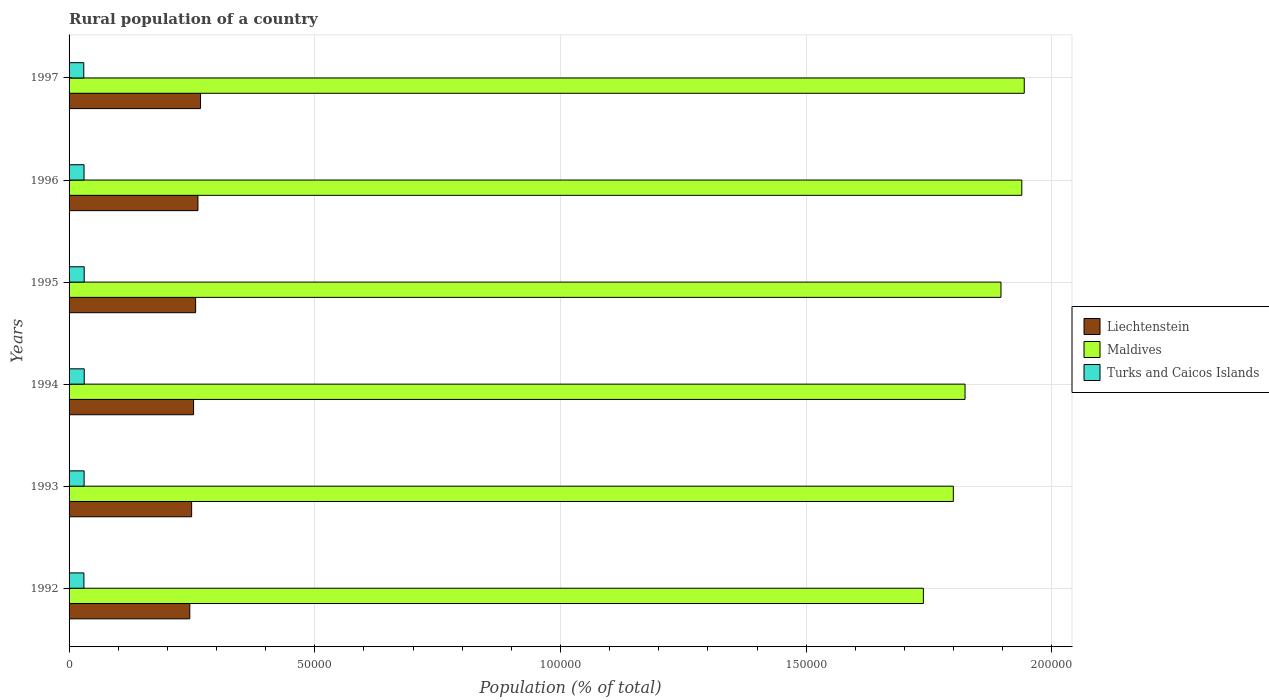How many groups of bars are there?
Your answer should be compact. 6. How many bars are there on the 3rd tick from the top?
Your answer should be compact. 3. In how many cases, is the number of bars for a given year not equal to the number of legend labels?
Give a very brief answer. 0. What is the rural population in Liechtenstein in 1997?
Offer a very short reply. 2.67e+04. Across all years, what is the maximum rural population in Liechtenstein?
Keep it short and to the point. 2.67e+04. Across all years, what is the minimum rural population in Liechtenstein?
Offer a very short reply. 2.46e+04. In which year was the rural population in Maldives minimum?
Make the answer very short. 1992. What is the total rural population in Liechtenstein in the graph?
Provide a short and direct response. 1.54e+05. What is the difference between the rural population in Turks and Caicos Islands in 1994 and that in 1995?
Keep it short and to the point. 4. What is the difference between the rural population in Liechtenstein in 1993 and the rural population in Turks and Caicos Islands in 1995?
Your answer should be very brief. 2.19e+04. What is the average rural population in Liechtenstein per year?
Offer a very short reply. 2.56e+04. In the year 1993, what is the difference between the rural population in Maldives and rural population in Turks and Caicos Islands?
Offer a terse response. 1.77e+05. In how many years, is the rural population in Turks and Caicos Islands greater than 170000 %?
Provide a succinct answer. 0. What is the ratio of the rural population in Liechtenstein in 1992 to that in 1997?
Make the answer very short. 0.92. What is the difference between the highest and the second highest rural population in Turks and Caicos Islands?
Your answer should be compact. 4. What is the difference between the highest and the lowest rural population in Turks and Caicos Islands?
Provide a succinct answer. 89. In how many years, is the rural population in Liechtenstein greater than the average rural population in Liechtenstein taken over all years?
Provide a succinct answer. 3. What does the 3rd bar from the top in 1994 represents?
Your answer should be very brief. Liechtenstein. What does the 1st bar from the bottom in 1993 represents?
Provide a succinct answer. Liechtenstein. Is it the case that in every year, the sum of the rural population in Maldives and rural population in Turks and Caicos Islands is greater than the rural population in Liechtenstein?
Your response must be concise. Yes. How many bars are there?
Provide a succinct answer. 18. How many years are there in the graph?
Your answer should be compact. 6. Are the values on the major ticks of X-axis written in scientific E-notation?
Keep it short and to the point. No. Does the graph contain any zero values?
Offer a terse response. No. Where does the legend appear in the graph?
Give a very brief answer. Center right. How are the legend labels stacked?
Your answer should be compact. Vertical. What is the title of the graph?
Your answer should be compact. Rural population of a country. What is the label or title of the X-axis?
Make the answer very short. Population (% of total). What is the Population (% of total) in Liechtenstein in 1992?
Ensure brevity in your answer.  2.46e+04. What is the Population (% of total) in Maldives in 1992?
Offer a very short reply. 1.74e+05. What is the Population (% of total) of Turks and Caicos Islands in 1992?
Your response must be concise. 3023. What is the Population (% of total) of Liechtenstein in 1993?
Provide a short and direct response. 2.49e+04. What is the Population (% of total) of Maldives in 1993?
Offer a terse response. 1.80e+05. What is the Population (% of total) in Turks and Caicos Islands in 1993?
Provide a short and direct response. 3061. What is the Population (% of total) of Liechtenstein in 1994?
Make the answer very short. 2.53e+04. What is the Population (% of total) of Maldives in 1994?
Make the answer very short. 1.82e+05. What is the Population (% of total) in Turks and Caicos Islands in 1994?
Keep it short and to the point. 3082. What is the Population (% of total) of Liechtenstein in 1995?
Your answer should be very brief. 2.58e+04. What is the Population (% of total) of Maldives in 1995?
Your response must be concise. 1.90e+05. What is the Population (% of total) in Turks and Caicos Islands in 1995?
Your answer should be very brief. 3078. What is the Population (% of total) of Liechtenstein in 1996?
Give a very brief answer. 2.62e+04. What is the Population (% of total) of Maldives in 1996?
Offer a terse response. 1.94e+05. What is the Population (% of total) of Turks and Caicos Islands in 1996?
Your answer should be very brief. 3045. What is the Population (% of total) of Liechtenstein in 1997?
Make the answer very short. 2.67e+04. What is the Population (% of total) in Maldives in 1997?
Offer a terse response. 1.94e+05. What is the Population (% of total) of Turks and Caicos Islands in 1997?
Provide a short and direct response. 2993. Across all years, what is the maximum Population (% of total) in Liechtenstein?
Ensure brevity in your answer.  2.67e+04. Across all years, what is the maximum Population (% of total) of Maldives?
Your answer should be compact. 1.94e+05. Across all years, what is the maximum Population (% of total) in Turks and Caicos Islands?
Your answer should be compact. 3082. Across all years, what is the minimum Population (% of total) in Liechtenstein?
Provide a short and direct response. 2.46e+04. Across all years, what is the minimum Population (% of total) of Maldives?
Your answer should be compact. 1.74e+05. Across all years, what is the minimum Population (% of total) of Turks and Caicos Islands?
Your response must be concise. 2993. What is the total Population (% of total) in Liechtenstein in the graph?
Ensure brevity in your answer.  1.54e+05. What is the total Population (% of total) in Maldives in the graph?
Provide a succinct answer. 1.11e+06. What is the total Population (% of total) in Turks and Caicos Islands in the graph?
Offer a very short reply. 1.83e+04. What is the difference between the Population (% of total) in Liechtenstein in 1992 and that in 1993?
Provide a short and direct response. -374. What is the difference between the Population (% of total) of Maldives in 1992 and that in 1993?
Provide a short and direct response. -6097. What is the difference between the Population (% of total) of Turks and Caicos Islands in 1992 and that in 1993?
Offer a terse response. -38. What is the difference between the Population (% of total) of Liechtenstein in 1992 and that in 1994?
Offer a very short reply. -770. What is the difference between the Population (% of total) of Maldives in 1992 and that in 1994?
Provide a short and direct response. -8482. What is the difference between the Population (% of total) of Turks and Caicos Islands in 1992 and that in 1994?
Provide a succinct answer. -59. What is the difference between the Population (% of total) of Liechtenstein in 1992 and that in 1995?
Your answer should be compact. -1186. What is the difference between the Population (% of total) of Maldives in 1992 and that in 1995?
Your answer should be compact. -1.58e+04. What is the difference between the Population (% of total) in Turks and Caicos Islands in 1992 and that in 1995?
Offer a terse response. -55. What is the difference between the Population (% of total) of Liechtenstein in 1992 and that in 1996?
Make the answer very short. -1659. What is the difference between the Population (% of total) of Maldives in 1992 and that in 1996?
Ensure brevity in your answer.  -2.00e+04. What is the difference between the Population (% of total) of Turks and Caicos Islands in 1992 and that in 1996?
Provide a succinct answer. -22. What is the difference between the Population (% of total) in Liechtenstein in 1992 and that in 1997?
Offer a very short reply. -2184. What is the difference between the Population (% of total) of Maldives in 1992 and that in 1997?
Keep it short and to the point. -2.05e+04. What is the difference between the Population (% of total) of Liechtenstein in 1993 and that in 1994?
Your response must be concise. -396. What is the difference between the Population (% of total) of Maldives in 1993 and that in 1994?
Your response must be concise. -2385. What is the difference between the Population (% of total) in Turks and Caicos Islands in 1993 and that in 1994?
Offer a very short reply. -21. What is the difference between the Population (% of total) of Liechtenstein in 1993 and that in 1995?
Provide a short and direct response. -812. What is the difference between the Population (% of total) of Maldives in 1993 and that in 1995?
Keep it short and to the point. -9694. What is the difference between the Population (% of total) of Turks and Caicos Islands in 1993 and that in 1995?
Provide a short and direct response. -17. What is the difference between the Population (% of total) of Liechtenstein in 1993 and that in 1996?
Provide a succinct answer. -1285. What is the difference between the Population (% of total) of Maldives in 1993 and that in 1996?
Keep it short and to the point. -1.39e+04. What is the difference between the Population (% of total) in Turks and Caicos Islands in 1993 and that in 1996?
Your response must be concise. 16. What is the difference between the Population (% of total) of Liechtenstein in 1993 and that in 1997?
Give a very brief answer. -1810. What is the difference between the Population (% of total) in Maldives in 1993 and that in 1997?
Provide a succinct answer. -1.44e+04. What is the difference between the Population (% of total) of Turks and Caicos Islands in 1993 and that in 1997?
Your answer should be compact. 68. What is the difference between the Population (% of total) in Liechtenstein in 1994 and that in 1995?
Your answer should be very brief. -416. What is the difference between the Population (% of total) of Maldives in 1994 and that in 1995?
Your answer should be compact. -7309. What is the difference between the Population (% of total) in Liechtenstein in 1994 and that in 1996?
Keep it short and to the point. -889. What is the difference between the Population (% of total) of Maldives in 1994 and that in 1996?
Provide a short and direct response. -1.15e+04. What is the difference between the Population (% of total) of Liechtenstein in 1994 and that in 1997?
Provide a short and direct response. -1414. What is the difference between the Population (% of total) of Maldives in 1994 and that in 1997?
Keep it short and to the point. -1.20e+04. What is the difference between the Population (% of total) of Turks and Caicos Islands in 1994 and that in 1997?
Offer a very short reply. 89. What is the difference between the Population (% of total) of Liechtenstein in 1995 and that in 1996?
Your answer should be compact. -473. What is the difference between the Population (% of total) in Maldives in 1995 and that in 1996?
Give a very brief answer. -4236. What is the difference between the Population (% of total) of Liechtenstein in 1995 and that in 1997?
Keep it short and to the point. -998. What is the difference between the Population (% of total) in Maldives in 1995 and that in 1997?
Provide a short and direct response. -4736. What is the difference between the Population (% of total) in Turks and Caicos Islands in 1995 and that in 1997?
Keep it short and to the point. 85. What is the difference between the Population (% of total) of Liechtenstein in 1996 and that in 1997?
Your answer should be very brief. -525. What is the difference between the Population (% of total) of Maldives in 1996 and that in 1997?
Your response must be concise. -500. What is the difference between the Population (% of total) of Turks and Caicos Islands in 1996 and that in 1997?
Make the answer very short. 52. What is the difference between the Population (% of total) in Liechtenstein in 1992 and the Population (% of total) in Maldives in 1993?
Provide a succinct answer. -1.55e+05. What is the difference between the Population (% of total) of Liechtenstein in 1992 and the Population (% of total) of Turks and Caicos Islands in 1993?
Keep it short and to the point. 2.15e+04. What is the difference between the Population (% of total) of Maldives in 1992 and the Population (% of total) of Turks and Caicos Islands in 1993?
Keep it short and to the point. 1.71e+05. What is the difference between the Population (% of total) in Liechtenstein in 1992 and the Population (% of total) in Maldives in 1994?
Offer a very short reply. -1.58e+05. What is the difference between the Population (% of total) in Liechtenstein in 1992 and the Population (% of total) in Turks and Caicos Islands in 1994?
Provide a short and direct response. 2.15e+04. What is the difference between the Population (% of total) of Maldives in 1992 and the Population (% of total) of Turks and Caicos Islands in 1994?
Keep it short and to the point. 1.71e+05. What is the difference between the Population (% of total) in Liechtenstein in 1992 and the Population (% of total) in Maldives in 1995?
Your answer should be compact. -1.65e+05. What is the difference between the Population (% of total) of Liechtenstein in 1992 and the Population (% of total) of Turks and Caicos Islands in 1995?
Ensure brevity in your answer.  2.15e+04. What is the difference between the Population (% of total) in Maldives in 1992 and the Population (% of total) in Turks and Caicos Islands in 1995?
Keep it short and to the point. 1.71e+05. What is the difference between the Population (% of total) of Liechtenstein in 1992 and the Population (% of total) of Maldives in 1996?
Your answer should be very brief. -1.69e+05. What is the difference between the Population (% of total) in Liechtenstein in 1992 and the Population (% of total) in Turks and Caicos Islands in 1996?
Keep it short and to the point. 2.15e+04. What is the difference between the Population (% of total) in Maldives in 1992 and the Population (% of total) in Turks and Caicos Islands in 1996?
Your answer should be very brief. 1.71e+05. What is the difference between the Population (% of total) of Liechtenstein in 1992 and the Population (% of total) of Maldives in 1997?
Provide a succinct answer. -1.70e+05. What is the difference between the Population (% of total) in Liechtenstein in 1992 and the Population (% of total) in Turks and Caicos Islands in 1997?
Provide a short and direct response. 2.16e+04. What is the difference between the Population (% of total) in Maldives in 1992 and the Population (% of total) in Turks and Caicos Islands in 1997?
Provide a succinct answer. 1.71e+05. What is the difference between the Population (% of total) of Liechtenstein in 1993 and the Population (% of total) of Maldives in 1994?
Your answer should be very brief. -1.57e+05. What is the difference between the Population (% of total) of Liechtenstein in 1993 and the Population (% of total) of Turks and Caicos Islands in 1994?
Your answer should be very brief. 2.19e+04. What is the difference between the Population (% of total) in Maldives in 1993 and the Population (% of total) in Turks and Caicos Islands in 1994?
Ensure brevity in your answer.  1.77e+05. What is the difference between the Population (% of total) of Liechtenstein in 1993 and the Population (% of total) of Maldives in 1995?
Your response must be concise. -1.65e+05. What is the difference between the Population (% of total) of Liechtenstein in 1993 and the Population (% of total) of Turks and Caicos Islands in 1995?
Your answer should be compact. 2.19e+04. What is the difference between the Population (% of total) in Maldives in 1993 and the Population (% of total) in Turks and Caicos Islands in 1995?
Give a very brief answer. 1.77e+05. What is the difference between the Population (% of total) in Liechtenstein in 1993 and the Population (% of total) in Maldives in 1996?
Provide a short and direct response. -1.69e+05. What is the difference between the Population (% of total) in Liechtenstein in 1993 and the Population (% of total) in Turks and Caicos Islands in 1996?
Make the answer very short. 2.19e+04. What is the difference between the Population (% of total) in Maldives in 1993 and the Population (% of total) in Turks and Caicos Islands in 1996?
Offer a terse response. 1.77e+05. What is the difference between the Population (% of total) in Liechtenstein in 1993 and the Population (% of total) in Maldives in 1997?
Provide a succinct answer. -1.69e+05. What is the difference between the Population (% of total) in Liechtenstein in 1993 and the Population (% of total) in Turks and Caicos Islands in 1997?
Make the answer very short. 2.19e+04. What is the difference between the Population (% of total) of Maldives in 1993 and the Population (% of total) of Turks and Caicos Islands in 1997?
Your answer should be very brief. 1.77e+05. What is the difference between the Population (% of total) in Liechtenstein in 1994 and the Population (% of total) in Maldives in 1995?
Give a very brief answer. -1.64e+05. What is the difference between the Population (% of total) in Liechtenstein in 1994 and the Population (% of total) in Turks and Caicos Islands in 1995?
Ensure brevity in your answer.  2.23e+04. What is the difference between the Population (% of total) of Maldives in 1994 and the Population (% of total) of Turks and Caicos Islands in 1995?
Offer a terse response. 1.79e+05. What is the difference between the Population (% of total) in Liechtenstein in 1994 and the Population (% of total) in Maldives in 1996?
Your response must be concise. -1.69e+05. What is the difference between the Population (% of total) of Liechtenstein in 1994 and the Population (% of total) of Turks and Caicos Islands in 1996?
Offer a very short reply. 2.23e+04. What is the difference between the Population (% of total) of Maldives in 1994 and the Population (% of total) of Turks and Caicos Islands in 1996?
Offer a very short reply. 1.79e+05. What is the difference between the Population (% of total) of Liechtenstein in 1994 and the Population (% of total) of Maldives in 1997?
Provide a succinct answer. -1.69e+05. What is the difference between the Population (% of total) of Liechtenstein in 1994 and the Population (% of total) of Turks and Caicos Islands in 1997?
Offer a terse response. 2.23e+04. What is the difference between the Population (% of total) of Maldives in 1994 and the Population (% of total) of Turks and Caicos Islands in 1997?
Provide a short and direct response. 1.79e+05. What is the difference between the Population (% of total) in Liechtenstein in 1995 and the Population (% of total) in Maldives in 1996?
Your response must be concise. -1.68e+05. What is the difference between the Population (% of total) in Liechtenstein in 1995 and the Population (% of total) in Turks and Caicos Islands in 1996?
Keep it short and to the point. 2.27e+04. What is the difference between the Population (% of total) of Maldives in 1995 and the Population (% of total) of Turks and Caicos Islands in 1996?
Make the answer very short. 1.87e+05. What is the difference between the Population (% of total) in Liechtenstein in 1995 and the Population (% of total) in Maldives in 1997?
Provide a short and direct response. -1.69e+05. What is the difference between the Population (% of total) of Liechtenstein in 1995 and the Population (% of total) of Turks and Caicos Islands in 1997?
Provide a short and direct response. 2.28e+04. What is the difference between the Population (% of total) of Maldives in 1995 and the Population (% of total) of Turks and Caicos Islands in 1997?
Offer a very short reply. 1.87e+05. What is the difference between the Population (% of total) in Liechtenstein in 1996 and the Population (% of total) in Maldives in 1997?
Your answer should be compact. -1.68e+05. What is the difference between the Population (% of total) in Liechtenstein in 1996 and the Population (% of total) in Turks and Caicos Islands in 1997?
Provide a succinct answer. 2.32e+04. What is the difference between the Population (% of total) in Maldives in 1996 and the Population (% of total) in Turks and Caicos Islands in 1997?
Give a very brief answer. 1.91e+05. What is the average Population (% of total) in Liechtenstein per year?
Provide a succinct answer. 2.56e+04. What is the average Population (% of total) in Maldives per year?
Provide a succinct answer. 1.86e+05. What is the average Population (% of total) of Turks and Caicos Islands per year?
Keep it short and to the point. 3047. In the year 1992, what is the difference between the Population (% of total) in Liechtenstein and Population (% of total) in Maldives?
Provide a succinct answer. -1.49e+05. In the year 1992, what is the difference between the Population (% of total) in Liechtenstein and Population (% of total) in Turks and Caicos Islands?
Make the answer very short. 2.15e+04. In the year 1992, what is the difference between the Population (% of total) in Maldives and Population (% of total) in Turks and Caicos Islands?
Make the answer very short. 1.71e+05. In the year 1993, what is the difference between the Population (% of total) in Liechtenstein and Population (% of total) in Maldives?
Your response must be concise. -1.55e+05. In the year 1993, what is the difference between the Population (% of total) in Liechtenstein and Population (% of total) in Turks and Caicos Islands?
Ensure brevity in your answer.  2.19e+04. In the year 1993, what is the difference between the Population (% of total) in Maldives and Population (% of total) in Turks and Caicos Islands?
Your answer should be very brief. 1.77e+05. In the year 1994, what is the difference between the Population (% of total) of Liechtenstein and Population (% of total) of Maldives?
Your answer should be very brief. -1.57e+05. In the year 1994, what is the difference between the Population (% of total) of Liechtenstein and Population (% of total) of Turks and Caicos Islands?
Provide a short and direct response. 2.23e+04. In the year 1994, what is the difference between the Population (% of total) in Maldives and Population (% of total) in Turks and Caicos Islands?
Ensure brevity in your answer.  1.79e+05. In the year 1995, what is the difference between the Population (% of total) in Liechtenstein and Population (% of total) in Maldives?
Your response must be concise. -1.64e+05. In the year 1995, what is the difference between the Population (% of total) in Liechtenstein and Population (% of total) in Turks and Caicos Islands?
Give a very brief answer. 2.27e+04. In the year 1995, what is the difference between the Population (% of total) of Maldives and Population (% of total) of Turks and Caicos Islands?
Offer a very short reply. 1.87e+05. In the year 1996, what is the difference between the Population (% of total) in Liechtenstein and Population (% of total) in Maldives?
Give a very brief answer. -1.68e+05. In the year 1996, what is the difference between the Population (% of total) in Liechtenstein and Population (% of total) in Turks and Caicos Islands?
Your response must be concise. 2.32e+04. In the year 1996, what is the difference between the Population (% of total) in Maldives and Population (% of total) in Turks and Caicos Islands?
Provide a succinct answer. 1.91e+05. In the year 1997, what is the difference between the Population (% of total) of Liechtenstein and Population (% of total) of Maldives?
Give a very brief answer. -1.68e+05. In the year 1997, what is the difference between the Population (% of total) of Liechtenstein and Population (% of total) of Turks and Caicos Islands?
Your response must be concise. 2.38e+04. In the year 1997, what is the difference between the Population (% of total) in Maldives and Population (% of total) in Turks and Caicos Islands?
Provide a short and direct response. 1.91e+05. What is the ratio of the Population (% of total) of Liechtenstein in 1992 to that in 1993?
Ensure brevity in your answer.  0.98. What is the ratio of the Population (% of total) in Maldives in 1992 to that in 1993?
Give a very brief answer. 0.97. What is the ratio of the Population (% of total) in Turks and Caicos Islands in 1992 to that in 1993?
Offer a very short reply. 0.99. What is the ratio of the Population (% of total) in Liechtenstein in 1992 to that in 1994?
Provide a short and direct response. 0.97. What is the ratio of the Population (% of total) of Maldives in 1992 to that in 1994?
Offer a terse response. 0.95. What is the ratio of the Population (% of total) in Turks and Caicos Islands in 1992 to that in 1994?
Your response must be concise. 0.98. What is the ratio of the Population (% of total) of Liechtenstein in 1992 to that in 1995?
Keep it short and to the point. 0.95. What is the ratio of the Population (% of total) of Turks and Caicos Islands in 1992 to that in 1995?
Give a very brief answer. 0.98. What is the ratio of the Population (% of total) of Liechtenstein in 1992 to that in 1996?
Give a very brief answer. 0.94. What is the ratio of the Population (% of total) in Maldives in 1992 to that in 1996?
Your answer should be very brief. 0.9. What is the ratio of the Population (% of total) of Liechtenstein in 1992 to that in 1997?
Give a very brief answer. 0.92. What is the ratio of the Population (% of total) in Maldives in 1992 to that in 1997?
Give a very brief answer. 0.89. What is the ratio of the Population (% of total) of Liechtenstein in 1993 to that in 1994?
Ensure brevity in your answer.  0.98. What is the ratio of the Population (% of total) of Maldives in 1993 to that in 1994?
Provide a succinct answer. 0.99. What is the ratio of the Population (% of total) of Liechtenstein in 1993 to that in 1995?
Offer a very short reply. 0.97. What is the ratio of the Population (% of total) of Maldives in 1993 to that in 1995?
Provide a short and direct response. 0.95. What is the ratio of the Population (% of total) of Turks and Caicos Islands in 1993 to that in 1995?
Provide a succinct answer. 0.99. What is the ratio of the Population (% of total) of Liechtenstein in 1993 to that in 1996?
Keep it short and to the point. 0.95. What is the ratio of the Population (% of total) in Maldives in 1993 to that in 1996?
Give a very brief answer. 0.93. What is the ratio of the Population (% of total) in Turks and Caicos Islands in 1993 to that in 1996?
Offer a terse response. 1.01. What is the ratio of the Population (% of total) of Liechtenstein in 1993 to that in 1997?
Give a very brief answer. 0.93. What is the ratio of the Population (% of total) of Maldives in 1993 to that in 1997?
Your answer should be very brief. 0.93. What is the ratio of the Population (% of total) in Turks and Caicos Islands in 1993 to that in 1997?
Offer a very short reply. 1.02. What is the ratio of the Population (% of total) of Liechtenstein in 1994 to that in 1995?
Keep it short and to the point. 0.98. What is the ratio of the Population (% of total) of Maldives in 1994 to that in 1995?
Offer a very short reply. 0.96. What is the ratio of the Population (% of total) of Turks and Caicos Islands in 1994 to that in 1995?
Offer a very short reply. 1. What is the ratio of the Population (% of total) of Liechtenstein in 1994 to that in 1996?
Your answer should be compact. 0.97. What is the ratio of the Population (% of total) in Maldives in 1994 to that in 1996?
Ensure brevity in your answer.  0.94. What is the ratio of the Population (% of total) of Turks and Caicos Islands in 1994 to that in 1996?
Provide a succinct answer. 1.01. What is the ratio of the Population (% of total) in Liechtenstein in 1994 to that in 1997?
Keep it short and to the point. 0.95. What is the ratio of the Population (% of total) in Maldives in 1994 to that in 1997?
Provide a succinct answer. 0.94. What is the ratio of the Population (% of total) of Turks and Caicos Islands in 1994 to that in 1997?
Make the answer very short. 1.03. What is the ratio of the Population (% of total) of Liechtenstein in 1995 to that in 1996?
Ensure brevity in your answer.  0.98. What is the ratio of the Population (% of total) of Maldives in 1995 to that in 1996?
Provide a succinct answer. 0.98. What is the ratio of the Population (% of total) of Turks and Caicos Islands in 1995 to that in 1996?
Your answer should be very brief. 1.01. What is the ratio of the Population (% of total) in Liechtenstein in 1995 to that in 1997?
Keep it short and to the point. 0.96. What is the ratio of the Population (% of total) in Maldives in 1995 to that in 1997?
Keep it short and to the point. 0.98. What is the ratio of the Population (% of total) of Turks and Caicos Islands in 1995 to that in 1997?
Provide a succinct answer. 1.03. What is the ratio of the Population (% of total) of Liechtenstein in 1996 to that in 1997?
Ensure brevity in your answer.  0.98. What is the ratio of the Population (% of total) in Turks and Caicos Islands in 1996 to that in 1997?
Your answer should be compact. 1.02. What is the difference between the highest and the second highest Population (% of total) in Liechtenstein?
Make the answer very short. 525. What is the difference between the highest and the second highest Population (% of total) of Maldives?
Keep it short and to the point. 500. What is the difference between the highest and the lowest Population (% of total) of Liechtenstein?
Give a very brief answer. 2184. What is the difference between the highest and the lowest Population (% of total) in Maldives?
Your answer should be very brief. 2.05e+04. What is the difference between the highest and the lowest Population (% of total) of Turks and Caicos Islands?
Ensure brevity in your answer.  89. 